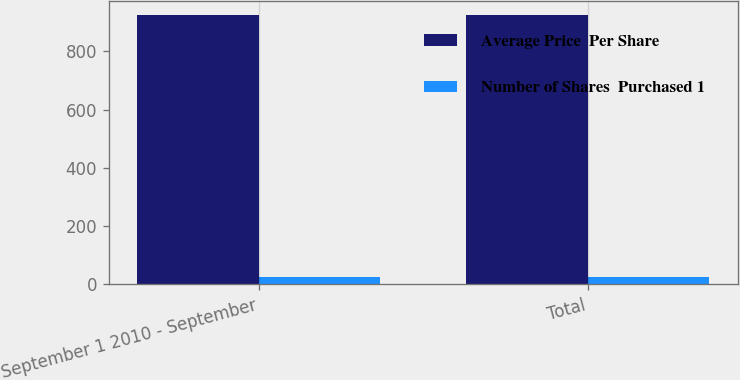Convert chart. <chart><loc_0><loc_0><loc_500><loc_500><stacked_bar_chart><ecel><fcel>September 1 2010 - September<fcel>Total<nl><fcel>Average Price  Per Share<fcel>926<fcel>926<nl><fcel>Number of Shares  Purchased 1<fcel>25.36<fcel>25.36<nl></chart> 